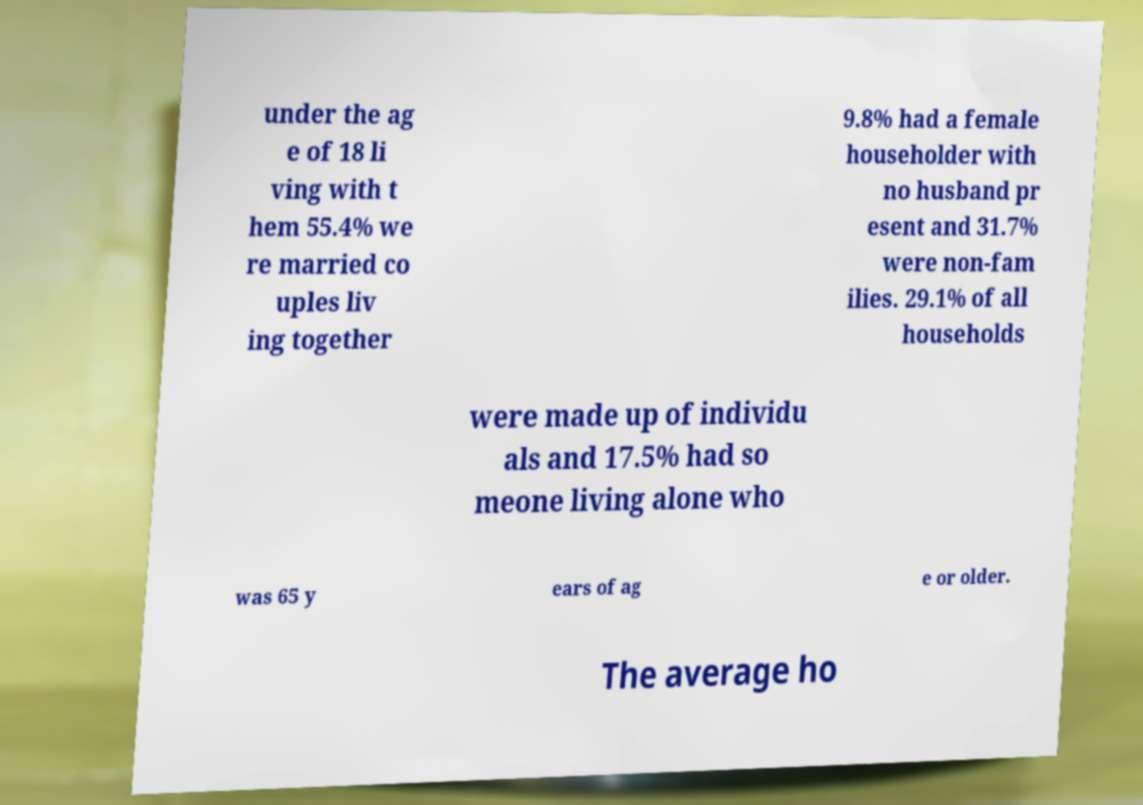What messages or text are displayed in this image? I need them in a readable, typed format. under the ag e of 18 li ving with t hem 55.4% we re married co uples liv ing together 9.8% had a female householder with no husband pr esent and 31.7% were non-fam ilies. 29.1% of all households were made up of individu als and 17.5% had so meone living alone who was 65 y ears of ag e or older. The average ho 